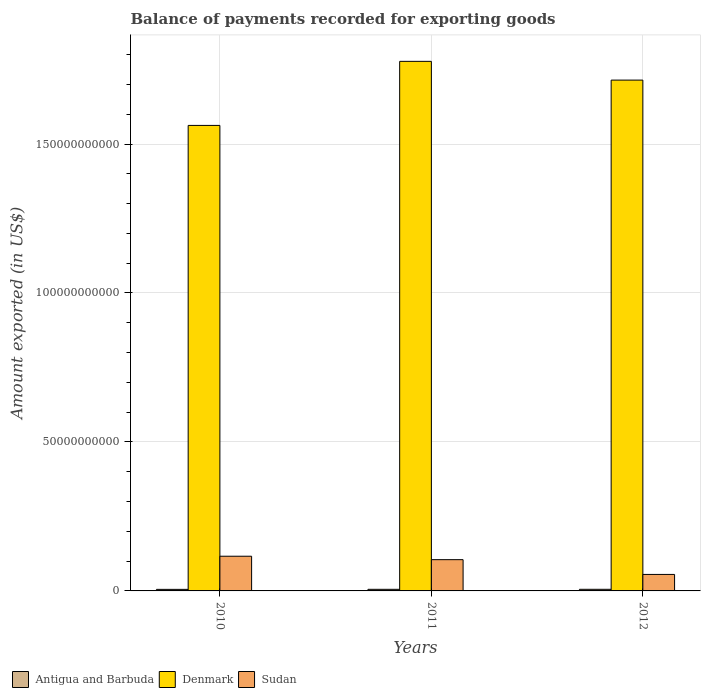How many different coloured bars are there?
Give a very brief answer. 3. Are the number of bars on each tick of the X-axis equal?
Your answer should be compact. Yes. What is the amount exported in Antigua and Barbuda in 2012?
Give a very brief answer. 5.42e+08. Across all years, what is the maximum amount exported in Antigua and Barbuda?
Provide a short and direct response. 5.42e+08. Across all years, what is the minimum amount exported in Denmark?
Give a very brief answer. 1.56e+11. In which year was the amount exported in Sudan maximum?
Ensure brevity in your answer.  2010. In which year was the amount exported in Antigua and Barbuda minimum?
Provide a short and direct response. 2010. What is the total amount exported in Antigua and Barbuda in the graph?
Your answer should be compact. 1.60e+09. What is the difference between the amount exported in Sudan in 2010 and that in 2012?
Offer a terse response. 6.11e+09. What is the difference between the amount exported in Denmark in 2011 and the amount exported in Sudan in 2012?
Provide a short and direct response. 1.72e+11. What is the average amount exported in Sudan per year?
Your response must be concise. 9.22e+09. In the year 2010, what is the difference between the amount exported in Sudan and amount exported in Antigua and Barbuda?
Offer a very short reply. 1.11e+1. In how many years, is the amount exported in Sudan greater than 150000000000 US$?
Keep it short and to the point. 0. What is the ratio of the amount exported in Denmark in 2011 to that in 2012?
Your answer should be very brief. 1.04. Is the amount exported in Antigua and Barbuda in 2010 less than that in 2011?
Keep it short and to the point. Yes. What is the difference between the highest and the second highest amount exported in Antigua and Barbuda?
Provide a short and direct response. 3.79e+06. What is the difference between the highest and the lowest amount exported in Antigua and Barbuda?
Provide a short and direct response. 1.77e+07. Is the sum of the amount exported in Antigua and Barbuda in 2010 and 2011 greater than the maximum amount exported in Denmark across all years?
Your answer should be very brief. No. What does the 3rd bar from the left in 2012 represents?
Offer a very short reply. Sudan. What does the 1st bar from the right in 2010 represents?
Offer a very short reply. Sudan. Is it the case that in every year, the sum of the amount exported in Antigua and Barbuda and amount exported in Denmark is greater than the amount exported in Sudan?
Keep it short and to the point. Yes. How many bars are there?
Ensure brevity in your answer.  9. Are all the bars in the graph horizontal?
Your answer should be very brief. No. Are the values on the major ticks of Y-axis written in scientific E-notation?
Make the answer very short. No. Where does the legend appear in the graph?
Keep it short and to the point. Bottom left. How are the legend labels stacked?
Offer a very short reply. Horizontal. What is the title of the graph?
Keep it short and to the point. Balance of payments recorded for exporting goods. Does "St. Vincent and the Grenadines" appear as one of the legend labels in the graph?
Your answer should be very brief. No. What is the label or title of the Y-axis?
Provide a succinct answer. Amount exported (in US$). What is the Amount exported (in US$) in Antigua and Barbuda in 2010?
Make the answer very short. 5.24e+08. What is the Amount exported (in US$) of Denmark in 2010?
Make the answer very short. 1.56e+11. What is the Amount exported (in US$) in Sudan in 2010?
Your answer should be very brief. 1.16e+1. What is the Amount exported (in US$) in Antigua and Barbuda in 2011?
Your response must be concise. 5.38e+08. What is the Amount exported (in US$) of Denmark in 2011?
Offer a very short reply. 1.78e+11. What is the Amount exported (in US$) of Sudan in 2011?
Your answer should be compact. 1.05e+1. What is the Amount exported (in US$) in Antigua and Barbuda in 2012?
Provide a succinct answer. 5.42e+08. What is the Amount exported (in US$) in Denmark in 2012?
Provide a succinct answer. 1.71e+11. What is the Amount exported (in US$) in Sudan in 2012?
Offer a terse response. 5.54e+09. Across all years, what is the maximum Amount exported (in US$) of Antigua and Barbuda?
Offer a terse response. 5.42e+08. Across all years, what is the maximum Amount exported (in US$) in Denmark?
Provide a short and direct response. 1.78e+11. Across all years, what is the maximum Amount exported (in US$) of Sudan?
Your answer should be compact. 1.16e+1. Across all years, what is the minimum Amount exported (in US$) in Antigua and Barbuda?
Offer a terse response. 5.24e+08. Across all years, what is the minimum Amount exported (in US$) of Denmark?
Make the answer very short. 1.56e+11. Across all years, what is the minimum Amount exported (in US$) of Sudan?
Provide a short and direct response. 5.54e+09. What is the total Amount exported (in US$) in Antigua and Barbuda in the graph?
Your answer should be compact. 1.60e+09. What is the total Amount exported (in US$) in Denmark in the graph?
Ensure brevity in your answer.  5.05e+11. What is the total Amount exported (in US$) in Sudan in the graph?
Offer a very short reply. 2.77e+1. What is the difference between the Amount exported (in US$) of Antigua and Barbuda in 2010 and that in 2011?
Provide a short and direct response. -1.39e+07. What is the difference between the Amount exported (in US$) of Denmark in 2010 and that in 2011?
Keep it short and to the point. -2.15e+1. What is the difference between the Amount exported (in US$) in Sudan in 2010 and that in 2011?
Your response must be concise. 1.16e+09. What is the difference between the Amount exported (in US$) in Antigua and Barbuda in 2010 and that in 2012?
Offer a very short reply. -1.77e+07. What is the difference between the Amount exported (in US$) of Denmark in 2010 and that in 2012?
Make the answer very short. -1.52e+1. What is the difference between the Amount exported (in US$) in Sudan in 2010 and that in 2012?
Your response must be concise. 6.11e+09. What is the difference between the Amount exported (in US$) in Antigua and Barbuda in 2011 and that in 2012?
Offer a terse response. -3.79e+06. What is the difference between the Amount exported (in US$) of Denmark in 2011 and that in 2012?
Offer a very short reply. 6.29e+09. What is the difference between the Amount exported (in US$) of Sudan in 2011 and that in 2012?
Keep it short and to the point. 4.95e+09. What is the difference between the Amount exported (in US$) in Antigua and Barbuda in 2010 and the Amount exported (in US$) in Denmark in 2011?
Offer a very short reply. -1.77e+11. What is the difference between the Amount exported (in US$) of Antigua and Barbuda in 2010 and the Amount exported (in US$) of Sudan in 2011?
Provide a succinct answer. -9.96e+09. What is the difference between the Amount exported (in US$) of Denmark in 2010 and the Amount exported (in US$) of Sudan in 2011?
Make the answer very short. 1.46e+11. What is the difference between the Amount exported (in US$) of Antigua and Barbuda in 2010 and the Amount exported (in US$) of Denmark in 2012?
Provide a succinct answer. -1.71e+11. What is the difference between the Amount exported (in US$) of Antigua and Barbuda in 2010 and the Amount exported (in US$) of Sudan in 2012?
Give a very brief answer. -5.01e+09. What is the difference between the Amount exported (in US$) of Denmark in 2010 and the Amount exported (in US$) of Sudan in 2012?
Offer a very short reply. 1.51e+11. What is the difference between the Amount exported (in US$) in Antigua and Barbuda in 2011 and the Amount exported (in US$) in Denmark in 2012?
Give a very brief answer. -1.71e+11. What is the difference between the Amount exported (in US$) in Antigua and Barbuda in 2011 and the Amount exported (in US$) in Sudan in 2012?
Provide a short and direct response. -5.00e+09. What is the difference between the Amount exported (in US$) in Denmark in 2011 and the Amount exported (in US$) in Sudan in 2012?
Provide a succinct answer. 1.72e+11. What is the average Amount exported (in US$) in Antigua and Barbuda per year?
Your answer should be very brief. 5.34e+08. What is the average Amount exported (in US$) in Denmark per year?
Offer a very short reply. 1.68e+11. What is the average Amount exported (in US$) of Sudan per year?
Keep it short and to the point. 9.22e+09. In the year 2010, what is the difference between the Amount exported (in US$) of Antigua and Barbuda and Amount exported (in US$) of Denmark?
Provide a succinct answer. -1.56e+11. In the year 2010, what is the difference between the Amount exported (in US$) of Antigua and Barbuda and Amount exported (in US$) of Sudan?
Give a very brief answer. -1.11e+1. In the year 2010, what is the difference between the Amount exported (in US$) of Denmark and Amount exported (in US$) of Sudan?
Your answer should be compact. 1.45e+11. In the year 2011, what is the difference between the Amount exported (in US$) in Antigua and Barbuda and Amount exported (in US$) in Denmark?
Ensure brevity in your answer.  -1.77e+11. In the year 2011, what is the difference between the Amount exported (in US$) in Antigua and Barbuda and Amount exported (in US$) in Sudan?
Your response must be concise. -9.95e+09. In the year 2011, what is the difference between the Amount exported (in US$) of Denmark and Amount exported (in US$) of Sudan?
Keep it short and to the point. 1.67e+11. In the year 2012, what is the difference between the Amount exported (in US$) in Antigua and Barbuda and Amount exported (in US$) in Denmark?
Offer a terse response. -1.71e+11. In the year 2012, what is the difference between the Amount exported (in US$) of Antigua and Barbuda and Amount exported (in US$) of Sudan?
Your response must be concise. -5.00e+09. In the year 2012, what is the difference between the Amount exported (in US$) in Denmark and Amount exported (in US$) in Sudan?
Your answer should be compact. 1.66e+11. What is the ratio of the Amount exported (in US$) in Antigua and Barbuda in 2010 to that in 2011?
Provide a succinct answer. 0.97. What is the ratio of the Amount exported (in US$) in Denmark in 2010 to that in 2011?
Offer a terse response. 0.88. What is the ratio of the Amount exported (in US$) of Sudan in 2010 to that in 2011?
Offer a very short reply. 1.11. What is the ratio of the Amount exported (in US$) of Antigua and Barbuda in 2010 to that in 2012?
Keep it short and to the point. 0.97. What is the ratio of the Amount exported (in US$) in Denmark in 2010 to that in 2012?
Offer a terse response. 0.91. What is the ratio of the Amount exported (in US$) in Sudan in 2010 to that in 2012?
Your answer should be compact. 2.1. What is the ratio of the Amount exported (in US$) of Antigua and Barbuda in 2011 to that in 2012?
Provide a short and direct response. 0.99. What is the ratio of the Amount exported (in US$) of Denmark in 2011 to that in 2012?
Keep it short and to the point. 1.04. What is the ratio of the Amount exported (in US$) of Sudan in 2011 to that in 2012?
Provide a succinct answer. 1.89. What is the difference between the highest and the second highest Amount exported (in US$) of Antigua and Barbuda?
Give a very brief answer. 3.79e+06. What is the difference between the highest and the second highest Amount exported (in US$) of Denmark?
Keep it short and to the point. 6.29e+09. What is the difference between the highest and the second highest Amount exported (in US$) in Sudan?
Offer a terse response. 1.16e+09. What is the difference between the highest and the lowest Amount exported (in US$) of Antigua and Barbuda?
Your answer should be very brief. 1.77e+07. What is the difference between the highest and the lowest Amount exported (in US$) of Denmark?
Offer a terse response. 2.15e+1. What is the difference between the highest and the lowest Amount exported (in US$) in Sudan?
Give a very brief answer. 6.11e+09. 